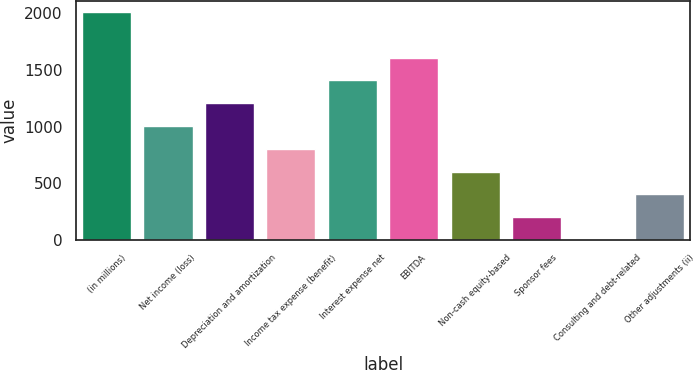<chart> <loc_0><loc_0><loc_500><loc_500><bar_chart><fcel>(in millions)<fcel>Net income (loss)<fcel>Depreciation and amortization<fcel>Income tax expense (benefit)<fcel>Interest expense net<fcel>EBITDA<fcel>Non-cash equity-based<fcel>Sponsor fees<fcel>Consulting and debt-related<fcel>Other adjustments (ii)<nl><fcel>2012<fcel>1006.3<fcel>1207.44<fcel>805.16<fcel>1408.58<fcel>1609.72<fcel>604.02<fcel>201.74<fcel>0.6<fcel>402.88<nl></chart> 